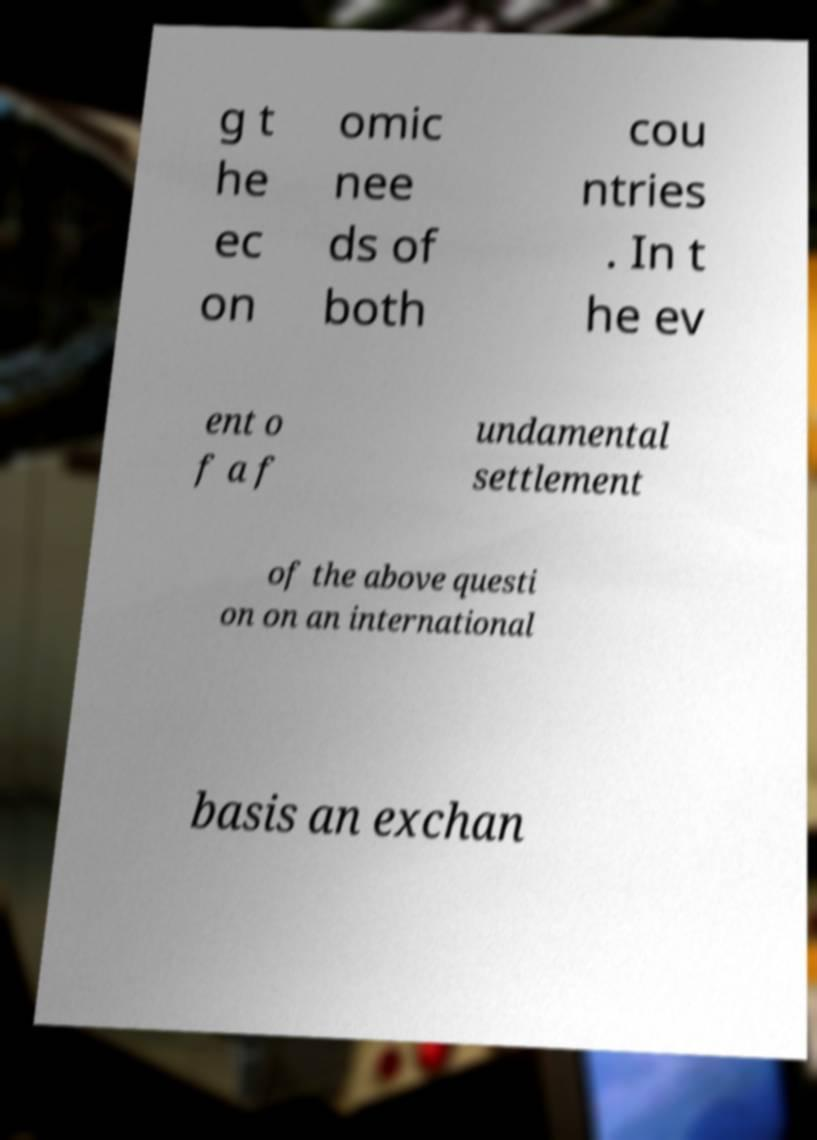I need the written content from this picture converted into text. Can you do that? g t he ec on omic nee ds of both cou ntries . In t he ev ent o f a f undamental settlement of the above questi on on an international basis an exchan 